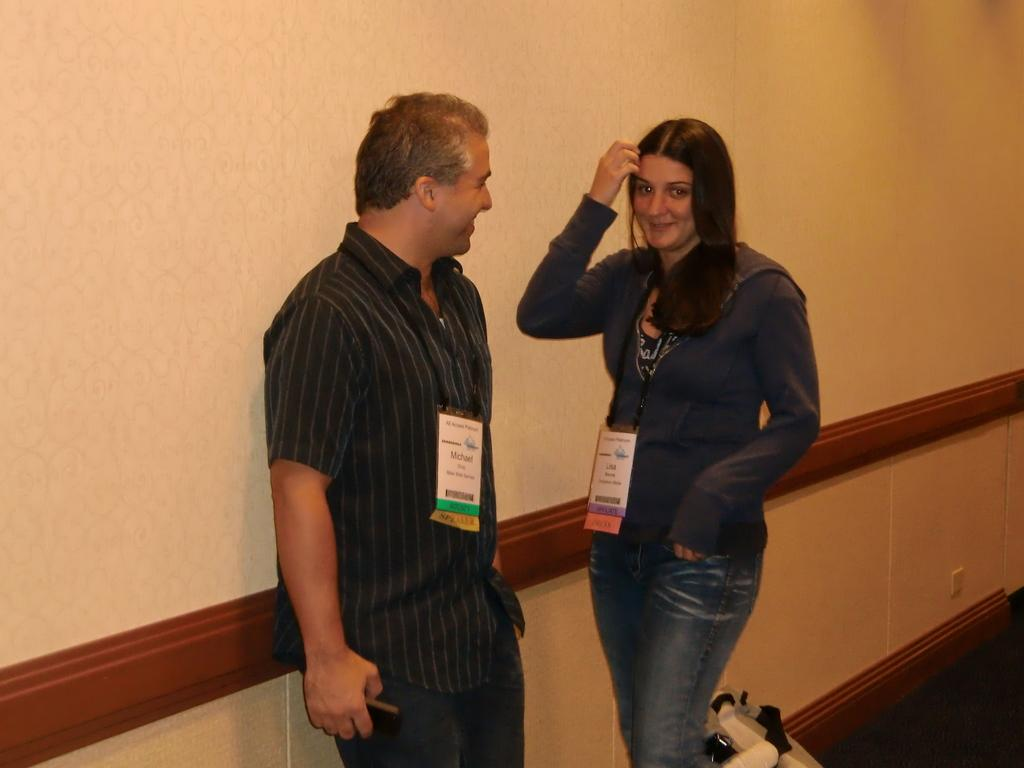How many people are in the foreground of the image? There are two people in the foreground of the image. What is the person on the left side of the image doing? The person on the left side of the image is holding a phone. What can be seen in the background of the image? There is a wall visible in the background of the image. Can you see any patches on the person's clothes in the image? There is no information about patches on the person's clothes in the image. 